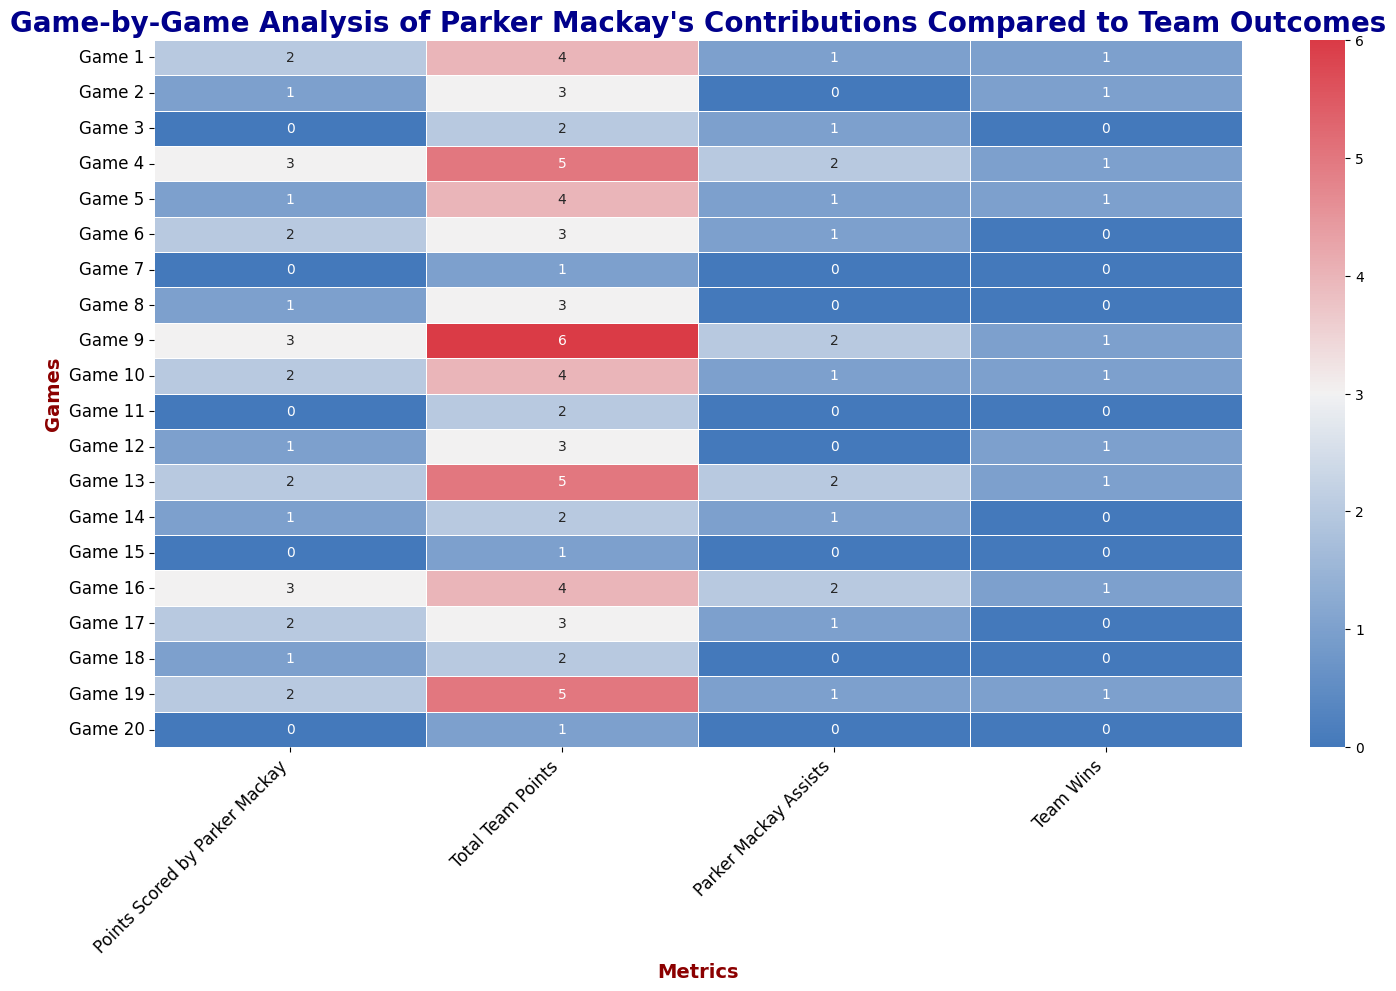How many games did Parker Mackay score 2 or more points? Check each game where Parker Mackay scored 2 or more points: Game 1, Game 4, Game 6, Game 9, Game 10, Game 13, Game 16, Game 17, Game 19
Answer: 9 Which game had the highest total team points and what were Parker Mackay's contributions in that game? Identify the game with the highest total team points (Game 9 with 6 points). Parker Mackay scored 3 points and had 2 assists in that game
Answer: Game 9, 3 points, 2 assists Did the team always win when Parker Mackay had 2 or more assists? Check the games where Parker Mackay had 2 or more assists (Game 4, Game 9, Game 13, Game 16). The team won in each of these games
Answer: Yes On average, how many points did Parker Mackay score in games where the team lost? Identify games where the team lost: Game 3, Game 6, Game 7, Game 8, Game 11, Game 14, Game 15, Game 17, Game 18, Game 20. Sum Parker Mackay's points in these games (0+2+0+1+0+1+0+2+1+0=7) and divide by the number of games (10). 7/10 = 0.7
Answer: 0.7 How does Parker Mackay's scoring compare between wins and losses? Calculate Parker Mackay's total points in wins (2+1+3+1+3+2+1+2+3+2=20) and losses (Shown in the previous answer: 7). Compare the averages: 20/10 = 2.0 for wins, and 7/10 = 0.7 for losses
Answer: Higher in wins (2.0 vs. 0.7) Which game had the lowest total team points and did Parker Mackay score any points in that game? Identify the game with the lowest total team points (Game 7 and Game 15 with 1 point each). Confirm that Parker Mackay scored 0 points in both games
Answer: Game 7 and Game 15, 0 points In how many games did Parker Mackay neither score points nor provide assists? Check each game for 0 points and 0 assists: Game 7, Game 11, Game 15, Game 20
Answer: 4 Compare Parker Mackay's average assists in wins versus losses. Calculate total assists in wins (1+0+2+1+2+1+1+2+1+1=12) and in losses (1+1+0+0+0+1+0+1+0+0=4). Divide by the number of games: for wins 12/10 = 1.2, and for losses 4/10 = 0.4
Answer: Higher in wins (1.2 vs. 0.4) Was there any game where Parker Mackay scored but the team did not win? Check games where Parker Mackay scored points and confirm team outcome: Game 6 (2 points), Game 14 (1 point), Game 18 (1 point)
Answer: Yes (Game 6, Game 14, Game 18) Which metrics appear to have the strongest visual correlation in the heatmap? Visually compare the colors of 'Points Scored by Parker Mackay' and 'Team Wins'. Darker colors in 'Points Scored by Parker Mackay' generally correspond to Team Wins
Answer: Points Scored by Parker Mackay and Team Wins 